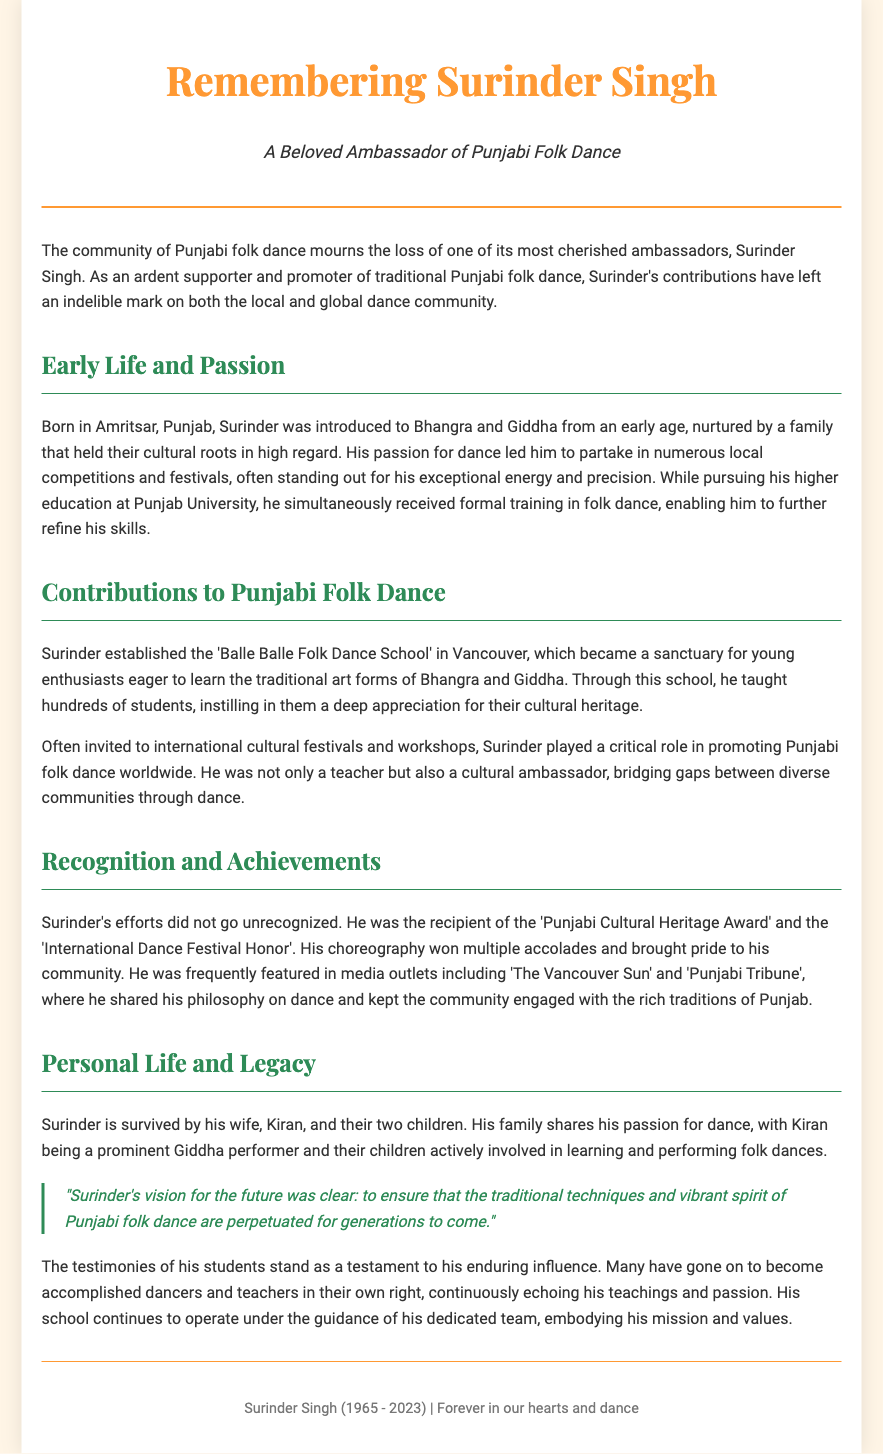What is the name of the Punjabi folk dance ambassador being remembered? The document focuses on Surinder Singh, highlighting his contributions and impact on the community.
Answer: Surinder Singh In which year was Surinder Singh born? The document states that Surinder Singh was born in 1965 and passed away in 2023.
Answer: 1965 What is the name of the dance school Surinder established? The document mentions that he established the 'Balle Balle Folk Dance School' to promote traditional Punjabi dance.
Answer: Balle Balle Folk Dance School What awards did Surinder Singh receive? The document lists the 'Punjabi Cultural Heritage Award' and the 'International Dance Festival Honor' among his recognition.
Answer: Punjabi Cultural Heritage Award, International Dance Festival Honor How many children did Surinder Singh have? The document indicates that Surinder is survived by his wife and their two children.
Answer: Two children What was Surinder's role at international cultural festivals? Surinder was not only a teacher but also a cultural ambassador, promoting Punjabi folk dance worldwide.
Answer: Cultural ambassador What was Surinder's educational background? The document details that he pursued higher education at Punjab University while receiving formal training in folk dance.
Answer: Punjab University What is one of the philosophies Surinder shared about dance? The document highlights that many of his students echo his teachings and passion for dance, indicating his profound influence.
Answer: "to ensure that the traditional techniques and vibrant spirit of Punjabi folk dance are perpetuated for generations to come" What is mentioned about Surinder’s family involvement in dance? The document states that his wife, Kiran, is a prominent Giddha performer, and their children are actively involved in dance.
Answer: Kiran and their children What city did Surinder Singh's dance school operate in? The document specifies that the 'Balle Balle Folk Dance School' is located in Vancouver.
Answer: Vancouver 